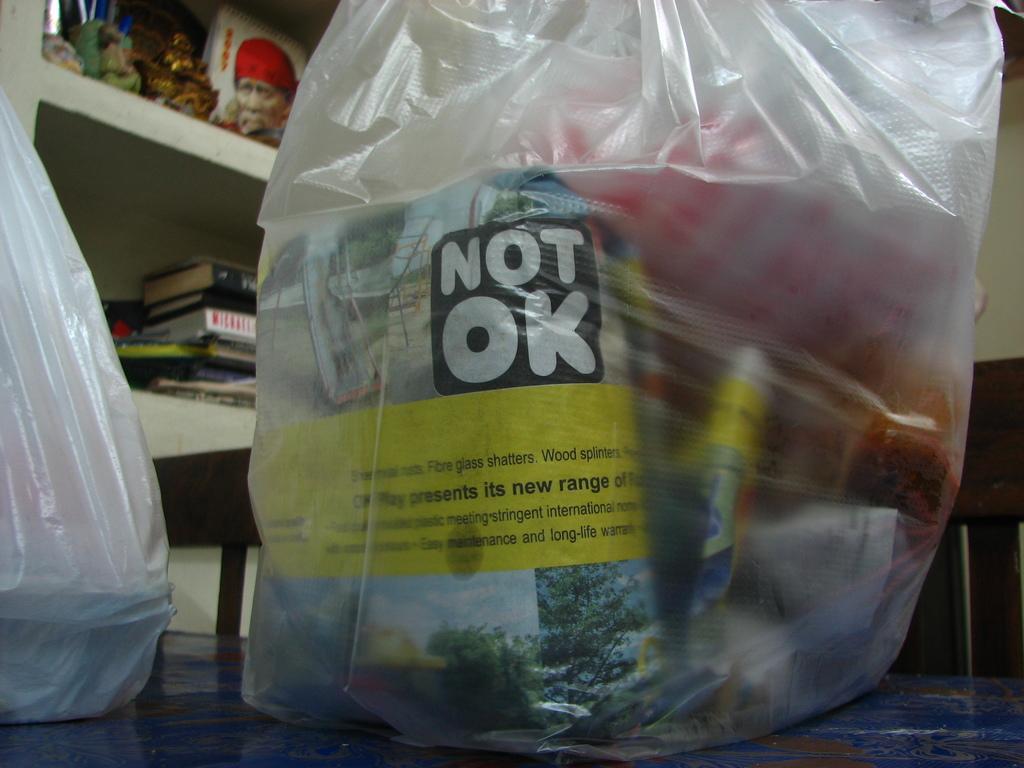Can you describe this image briefly? In the image we can see plastic covers, in it we can see some objects. Here we can see the photo of the god and the books. 